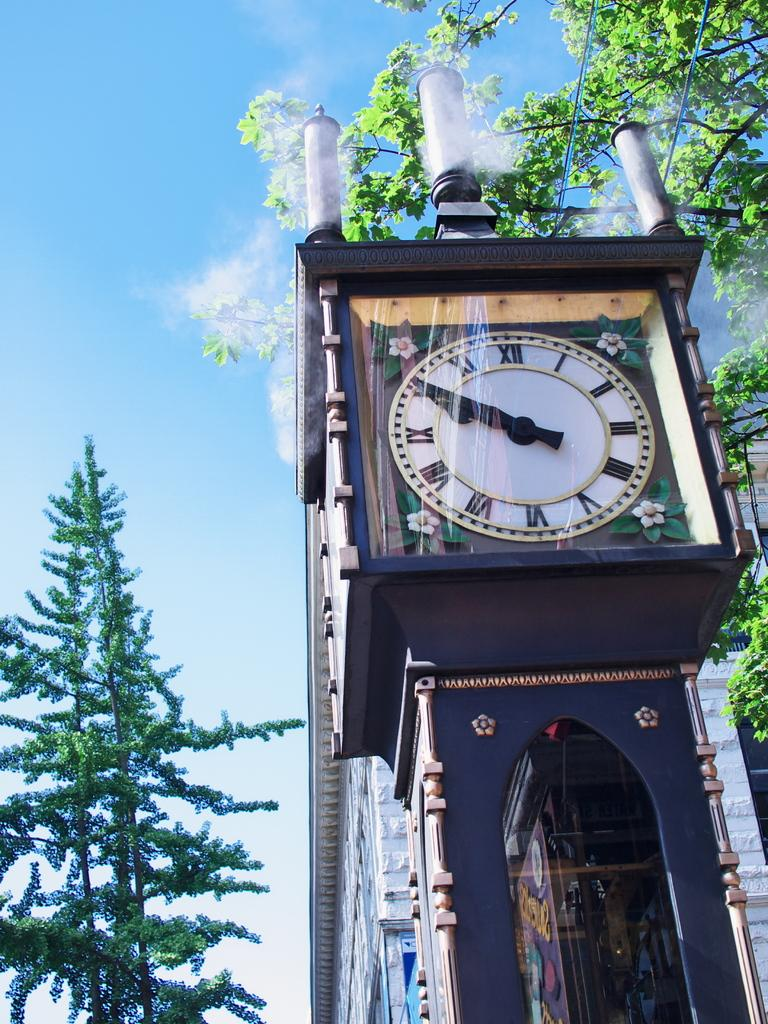What is on the building in the image? There is a clock on a building in the image. What type of vegetation can be seen on both sides of the image? There are trees on the right side and the left side of the image. What is the color of the sky in the image? The sky is blue in color. Who is the creator of the trees in the image? The trees in the image are natural vegetation and do not have a specific creator. 